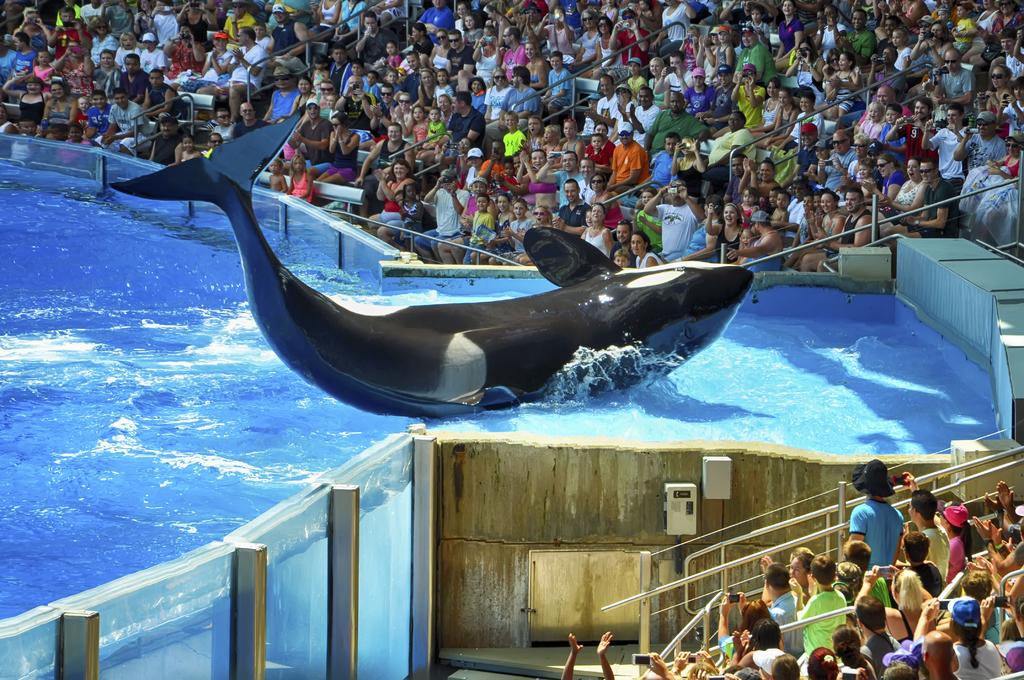How many people are in the group visible in the image? There is a group of people in the image, but the exact number is not specified. What are some people in the group holding? Some people in the group are holding something, but the specific objects are not mentioned. What type of animal is present in the image? There is a dolphin in the image. What type of barrier is visible in the image? There is fencing in the image. What natural element is visible in the image? There is water visible in the image. What type of ornament is hanging from the dolphin's fin in the image? There is no ornament hanging from the dolphin's fin in the image. What type of prison is visible in the image? There is no prison visible in the image. 